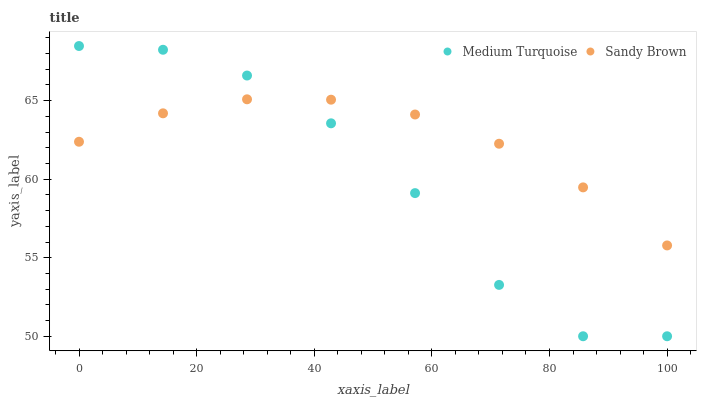Does Medium Turquoise have the minimum area under the curve?
Answer yes or no. Yes. Does Sandy Brown have the maximum area under the curve?
Answer yes or no. Yes. Does Medium Turquoise have the maximum area under the curve?
Answer yes or no. No. Is Sandy Brown the smoothest?
Answer yes or no. Yes. Is Medium Turquoise the roughest?
Answer yes or no. Yes. Is Medium Turquoise the smoothest?
Answer yes or no. No. Does Medium Turquoise have the lowest value?
Answer yes or no. Yes. Does Medium Turquoise have the highest value?
Answer yes or no. Yes. Does Medium Turquoise intersect Sandy Brown?
Answer yes or no. Yes. Is Medium Turquoise less than Sandy Brown?
Answer yes or no. No. Is Medium Turquoise greater than Sandy Brown?
Answer yes or no. No. 